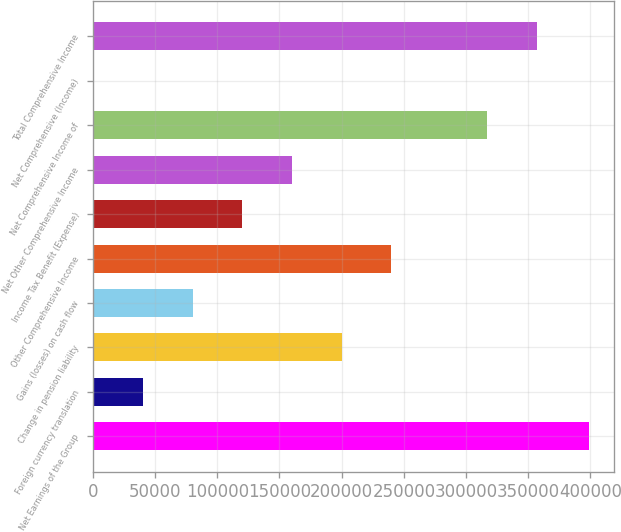Convert chart. <chart><loc_0><loc_0><loc_500><loc_500><bar_chart><fcel>Net Earnings of the Group<fcel>Foreign currency translation<fcel>Change in pension liability<fcel>Gains (losses) on cash flow<fcel>Other Comprehensive Income<fcel>Income Tax Benefit (Expense)<fcel>Net Other Comprehensive Income<fcel>Net Comprehensive Income of<fcel>Net Comprehensive (Income)<fcel>Total Comprehensive Income<nl><fcel>399213<fcel>40498.2<fcel>199927<fcel>80355.4<fcel>239784<fcel>120213<fcel>160070<fcel>316968<fcel>641<fcel>356825<nl></chart> 